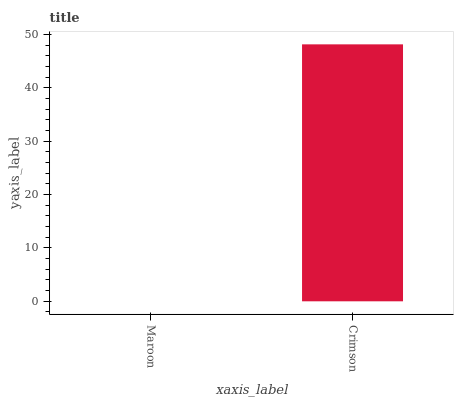Is Maroon the minimum?
Answer yes or no. Yes. Is Crimson the maximum?
Answer yes or no. Yes. Is Crimson the minimum?
Answer yes or no. No. Is Crimson greater than Maroon?
Answer yes or no. Yes. Is Maroon less than Crimson?
Answer yes or no. Yes. Is Maroon greater than Crimson?
Answer yes or no. No. Is Crimson less than Maroon?
Answer yes or no. No. Is Crimson the high median?
Answer yes or no. Yes. Is Maroon the low median?
Answer yes or no. Yes. Is Maroon the high median?
Answer yes or no. No. Is Crimson the low median?
Answer yes or no. No. 